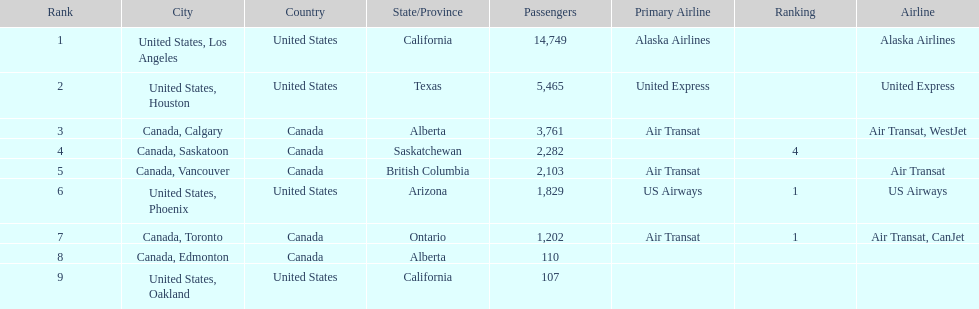How many cities from canada are on this list? 5. 